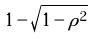Convert formula to latex. <formula><loc_0><loc_0><loc_500><loc_500>1 - \sqrt { 1 - \rho ^ { 2 } }</formula> 